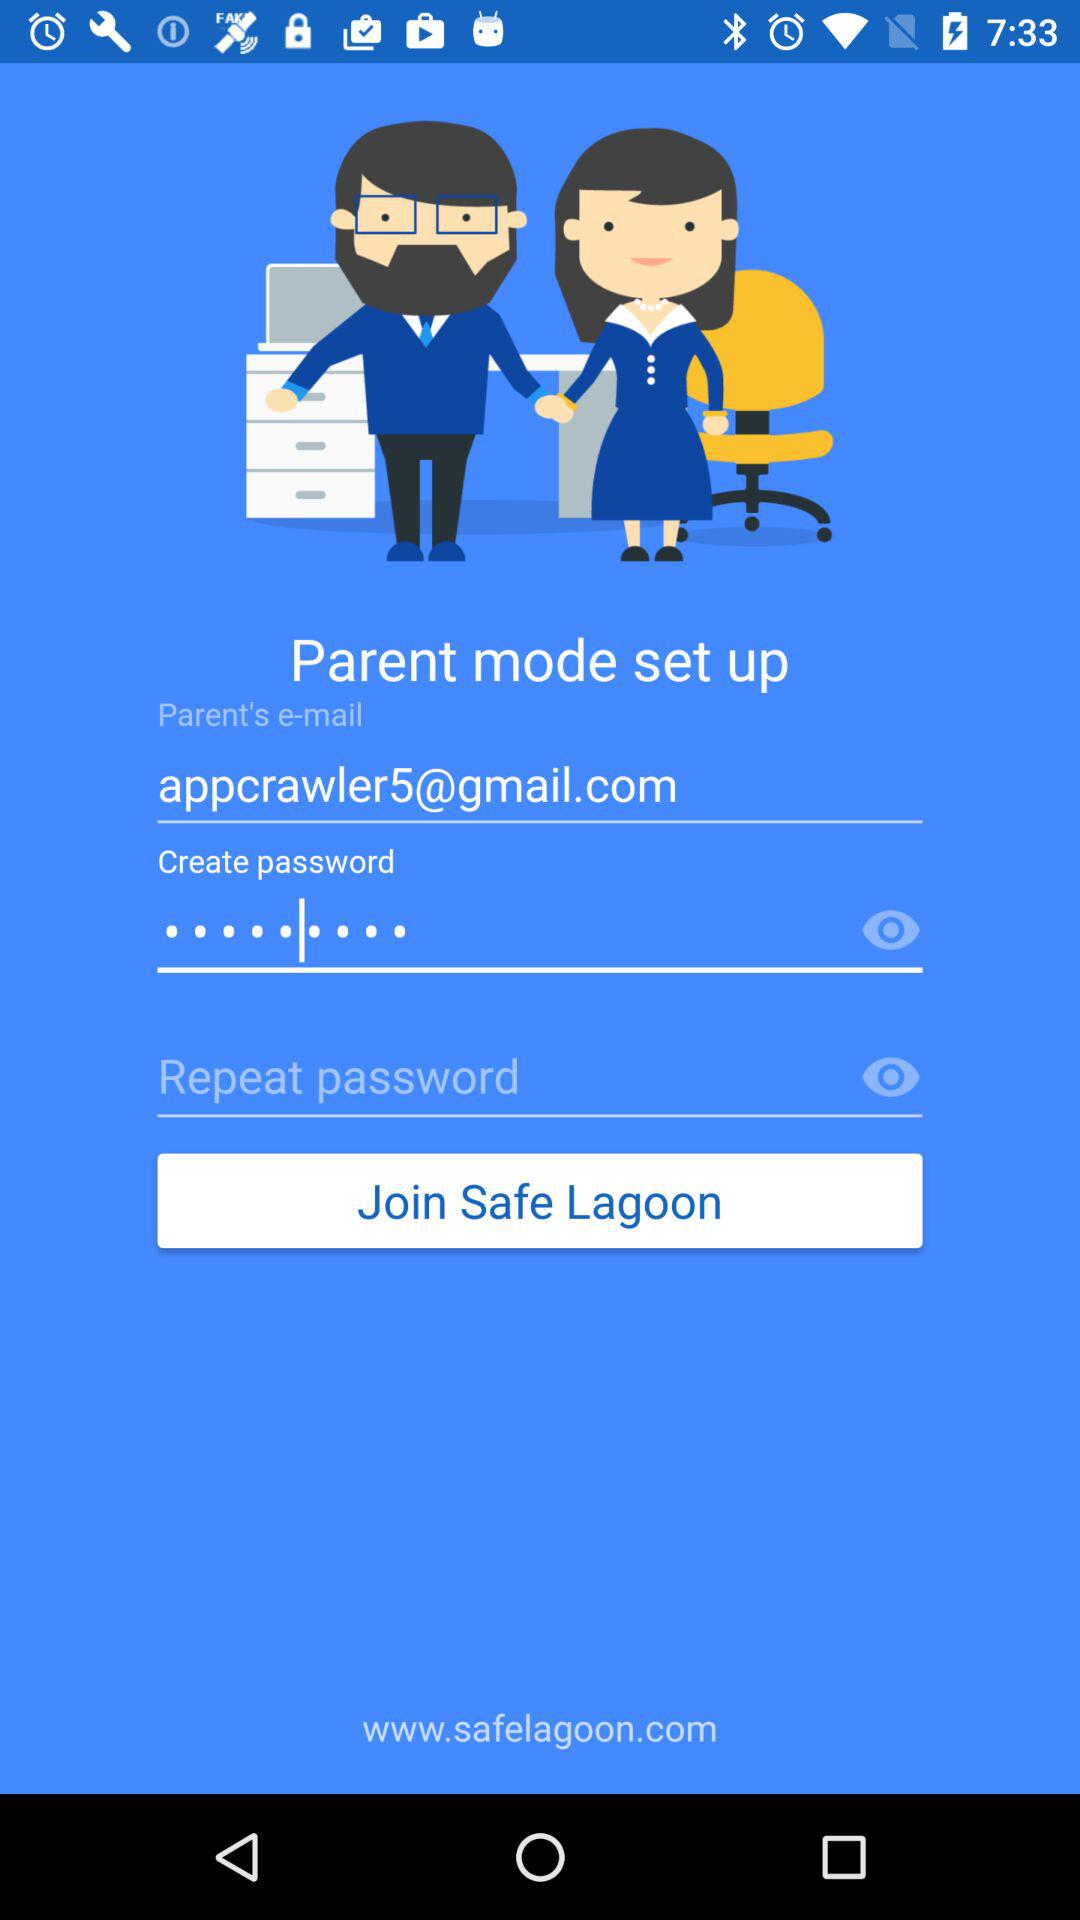What is the application's website address? The application's website address is www.safelagoon.com. 